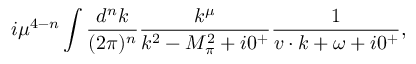Convert formula to latex. <formula><loc_0><loc_0><loc_500><loc_500>i \mu ^ { 4 - n } \int \frac { d ^ { n } k } { ( 2 \pi ) ^ { n } } \frac { k ^ { \mu } } { k ^ { 2 } - M _ { \pi } ^ { 2 } + i 0 ^ { + } } \frac { 1 } { v \cdot k + \omega + i 0 ^ { + } } ,</formula> 